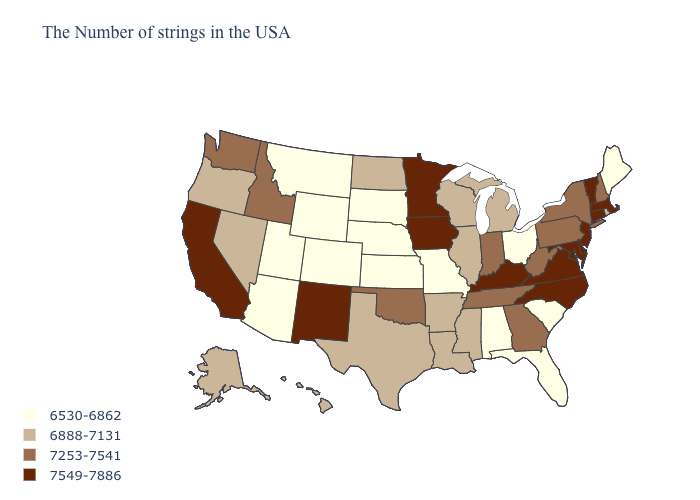Does Oregon have the same value as Indiana?
Be succinct. No. Among the states that border Ohio , which have the lowest value?
Write a very short answer. Michigan. Does the map have missing data?
Quick response, please. No. Does Kentucky have the highest value in the USA?
Write a very short answer. Yes. Is the legend a continuous bar?
Concise answer only. No. Name the states that have a value in the range 6888-7131?
Short answer required. Rhode Island, Michigan, Wisconsin, Illinois, Mississippi, Louisiana, Arkansas, Texas, North Dakota, Nevada, Oregon, Alaska, Hawaii. What is the highest value in the USA?
Quick response, please. 7549-7886. Does Wyoming have the same value as New York?
Answer briefly. No. Which states have the highest value in the USA?
Concise answer only. Massachusetts, Vermont, Connecticut, New Jersey, Delaware, Maryland, Virginia, North Carolina, Kentucky, Minnesota, Iowa, New Mexico, California. Which states have the lowest value in the South?
Give a very brief answer. South Carolina, Florida, Alabama. Does Montana have the same value as Delaware?
Write a very short answer. No. What is the value of Alabama?
Quick response, please. 6530-6862. Does the map have missing data?
Short answer required. No. Among the states that border Florida , does Georgia have the highest value?
Give a very brief answer. Yes. Name the states that have a value in the range 6530-6862?
Quick response, please. Maine, South Carolina, Ohio, Florida, Alabama, Missouri, Kansas, Nebraska, South Dakota, Wyoming, Colorado, Utah, Montana, Arizona. 